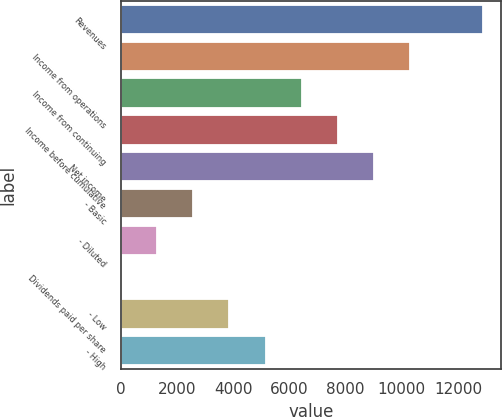Convert chart. <chart><loc_0><loc_0><loc_500><loc_500><bar_chart><fcel>Revenues<fcel>Income from operations<fcel>Income from continuing<fcel>Income before cumulative<fcel>Net income<fcel>- Basic<fcel>- Diluted<fcel>Dividends paid per share<fcel>- Low<fcel>- High<nl><fcel>12879<fcel>10303.2<fcel>6439.63<fcel>7727.5<fcel>9015.37<fcel>2576.02<fcel>1288.15<fcel>0.28<fcel>3863.89<fcel>5151.76<nl></chart> 